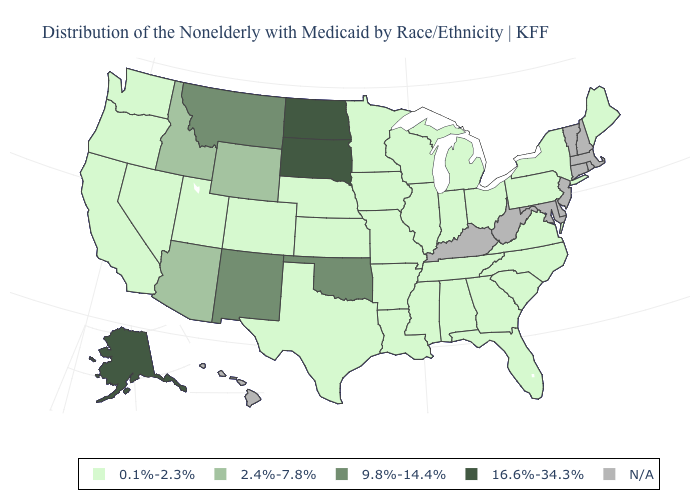What is the value of Maryland?
Keep it brief. N/A. What is the value of New Jersey?
Keep it brief. N/A. Name the states that have a value in the range 2.4%-7.8%?
Concise answer only. Arizona, Idaho, Wyoming. What is the lowest value in the Northeast?
Concise answer only. 0.1%-2.3%. What is the lowest value in the USA?
Answer briefly. 0.1%-2.3%. What is the value of Connecticut?
Give a very brief answer. N/A. What is the value of Nebraska?
Write a very short answer. 0.1%-2.3%. What is the value of Minnesota?
Quick response, please. 0.1%-2.3%. Which states have the highest value in the USA?
Quick response, please. Alaska, North Dakota, South Dakota. What is the value of Kentucky?
Concise answer only. N/A. Does Indiana have the highest value in the MidWest?
Answer briefly. No. Among the states that border North Dakota , which have the highest value?
Concise answer only. South Dakota. Among the states that border Wisconsin , which have the highest value?
Quick response, please. Illinois, Iowa, Michigan, Minnesota. What is the value of Washington?
Write a very short answer. 0.1%-2.3%. 